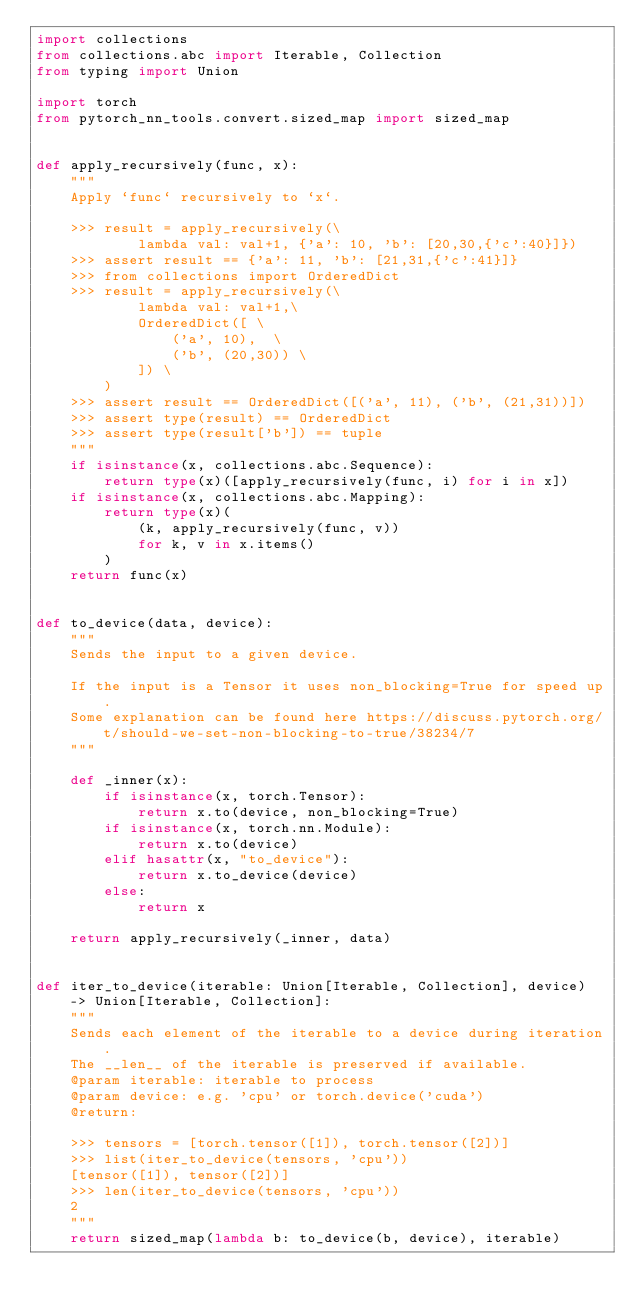Convert code to text. <code><loc_0><loc_0><loc_500><loc_500><_Python_>import collections
from collections.abc import Iterable, Collection
from typing import Union

import torch
from pytorch_nn_tools.convert.sized_map import sized_map


def apply_recursively(func, x):
    """
    Apply `func` recursively to `x`.

    >>> result = apply_recursively(\
            lambda val: val+1, {'a': 10, 'b': [20,30,{'c':40}]})
    >>> assert result == {'a': 11, 'b': [21,31,{'c':41}]}
    >>> from collections import OrderedDict
    >>> result = apply_recursively(\
            lambda val: val+1,\
            OrderedDict([ \
                ('a', 10),  \
                ('b', (20,30)) \
            ]) \
        )
    >>> assert result == OrderedDict([('a', 11), ('b', (21,31))])
    >>> assert type(result) == OrderedDict
    >>> assert type(result['b']) == tuple
    """
    if isinstance(x, collections.abc.Sequence):
        return type(x)([apply_recursively(func, i) for i in x])
    if isinstance(x, collections.abc.Mapping):
        return type(x)(
            (k, apply_recursively(func, v))
            for k, v in x.items()
        )
    return func(x)


def to_device(data, device):
    """
    Sends the input to a given device.

    If the input is a Tensor it uses non_blocking=True for speed up.
    Some explanation can be found here https://discuss.pytorch.org/t/should-we-set-non-blocking-to-true/38234/7
    """

    def _inner(x):
        if isinstance(x, torch.Tensor):
            return x.to(device, non_blocking=True)
        if isinstance(x, torch.nn.Module):
            return x.to(device)
        elif hasattr(x, "to_device"):
            return x.to_device(device)
        else:
            return x

    return apply_recursively(_inner, data)


def iter_to_device(iterable: Union[Iterable, Collection], device) -> Union[Iterable, Collection]:
    """
    Sends each element of the iterable to a device during iteration.
    The __len__ of the iterable is preserved if available.
    @param iterable: iterable to process
    @param device: e.g. 'cpu' or torch.device('cuda')
    @return:

    >>> tensors = [torch.tensor([1]), torch.tensor([2])]
    >>> list(iter_to_device(tensors, 'cpu'))
    [tensor([1]), tensor([2])]
    >>> len(iter_to_device(tensors, 'cpu'))
    2
    """
    return sized_map(lambda b: to_device(b, device), iterable)
</code> 